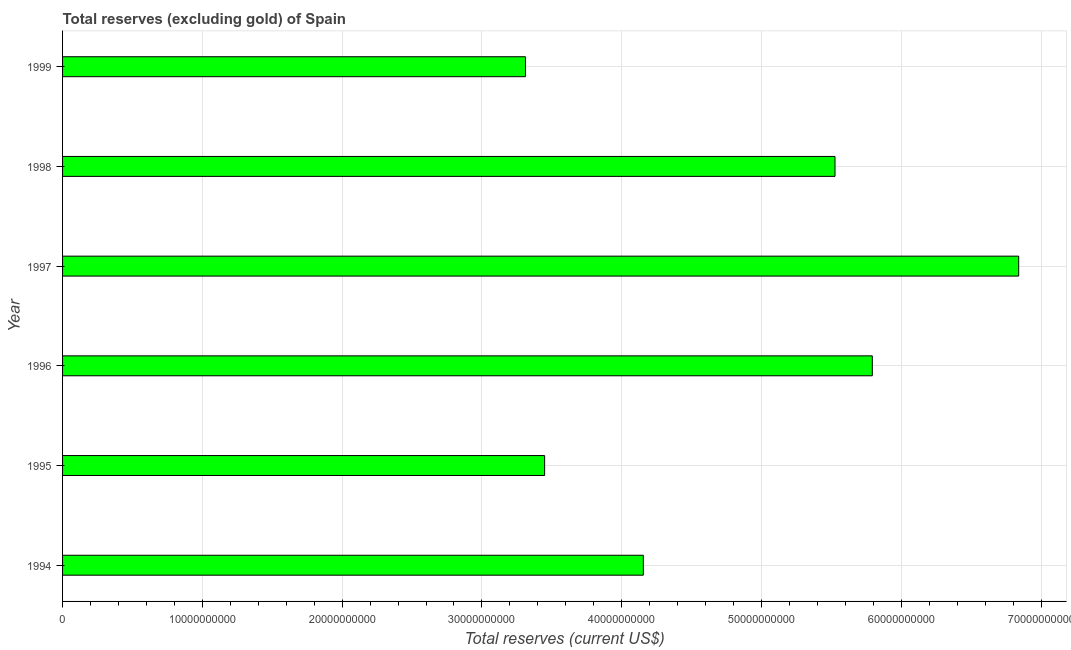Does the graph contain grids?
Offer a terse response. Yes. What is the title of the graph?
Your answer should be compact. Total reserves (excluding gold) of Spain. What is the label or title of the X-axis?
Your answer should be compact. Total reserves (current US$). What is the total reserves (excluding gold) in 1998?
Offer a terse response. 5.53e+1. Across all years, what is the maximum total reserves (excluding gold)?
Provide a succinct answer. 6.84e+1. Across all years, what is the minimum total reserves (excluding gold)?
Offer a terse response. 3.31e+1. In which year was the total reserves (excluding gold) maximum?
Give a very brief answer. 1997. What is the sum of the total reserves (excluding gold)?
Your response must be concise. 2.91e+11. What is the difference between the total reserves (excluding gold) in 1997 and 1998?
Keep it short and to the point. 1.31e+1. What is the average total reserves (excluding gold) per year?
Your answer should be very brief. 4.85e+1. What is the median total reserves (excluding gold)?
Your answer should be very brief. 4.84e+1. In how many years, is the total reserves (excluding gold) greater than 52000000000 US$?
Make the answer very short. 3. What is the ratio of the total reserves (excluding gold) in 1997 to that in 1998?
Keep it short and to the point. 1.24. What is the difference between the highest and the second highest total reserves (excluding gold)?
Ensure brevity in your answer.  1.05e+1. What is the difference between the highest and the lowest total reserves (excluding gold)?
Provide a short and direct response. 3.53e+1. In how many years, is the total reserves (excluding gold) greater than the average total reserves (excluding gold) taken over all years?
Offer a terse response. 3. Are all the bars in the graph horizontal?
Give a very brief answer. Yes. How many years are there in the graph?
Your response must be concise. 6. What is the difference between two consecutive major ticks on the X-axis?
Offer a terse response. 1.00e+1. What is the Total reserves (current US$) in 1994?
Keep it short and to the point. 4.15e+1. What is the Total reserves (current US$) in 1995?
Your answer should be compact. 3.45e+1. What is the Total reserves (current US$) of 1996?
Make the answer very short. 5.79e+1. What is the Total reserves (current US$) of 1997?
Make the answer very short. 6.84e+1. What is the Total reserves (current US$) of 1998?
Provide a succinct answer. 5.53e+1. What is the Total reserves (current US$) in 1999?
Offer a very short reply. 3.31e+1. What is the difference between the Total reserves (current US$) in 1994 and 1995?
Ensure brevity in your answer.  7.06e+09. What is the difference between the Total reserves (current US$) in 1994 and 1996?
Make the answer very short. -1.64e+1. What is the difference between the Total reserves (current US$) in 1994 and 1997?
Provide a succinct answer. -2.69e+1. What is the difference between the Total reserves (current US$) in 1994 and 1998?
Keep it short and to the point. -1.37e+1. What is the difference between the Total reserves (current US$) in 1994 and 1999?
Offer a terse response. 8.43e+09. What is the difference between the Total reserves (current US$) in 1995 and 1996?
Ensure brevity in your answer.  -2.34e+1. What is the difference between the Total reserves (current US$) in 1995 and 1997?
Keep it short and to the point. -3.39e+1. What is the difference between the Total reserves (current US$) in 1995 and 1998?
Make the answer very short. -2.08e+1. What is the difference between the Total reserves (current US$) in 1995 and 1999?
Ensure brevity in your answer.  1.37e+09. What is the difference between the Total reserves (current US$) in 1996 and 1997?
Make the answer very short. -1.05e+1. What is the difference between the Total reserves (current US$) in 1996 and 1998?
Offer a terse response. 2.67e+09. What is the difference between the Total reserves (current US$) in 1996 and 1999?
Your answer should be very brief. 2.48e+1. What is the difference between the Total reserves (current US$) in 1997 and 1998?
Your answer should be compact. 1.31e+1. What is the difference between the Total reserves (current US$) in 1997 and 1999?
Offer a very short reply. 3.53e+1. What is the difference between the Total reserves (current US$) in 1998 and 1999?
Your answer should be very brief. 2.21e+1. What is the ratio of the Total reserves (current US$) in 1994 to that in 1995?
Ensure brevity in your answer.  1.21. What is the ratio of the Total reserves (current US$) in 1994 to that in 1996?
Your answer should be very brief. 0.72. What is the ratio of the Total reserves (current US$) in 1994 to that in 1997?
Ensure brevity in your answer.  0.61. What is the ratio of the Total reserves (current US$) in 1994 to that in 1998?
Keep it short and to the point. 0.75. What is the ratio of the Total reserves (current US$) in 1994 to that in 1999?
Provide a short and direct response. 1.25. What is the ratio of the Total reserves (current US$) in 1995 to that in 1996?
Provide a succinct answer. 0.59. What is the ratio of the Total reserves (current US$) in 1995 to that in 1997?
Provide a succinct answer. 0.5. What is the ratio of the Total reserves (current US$) in 1995 to that in 1998?
Provide a short and direct response. 0.62. What is the ratio of the Total reserves (current US$) in 1995 to that in 1999?
Provide a short and direct response. 1.04. What is the ratio of the Total reserves (current US$) in 1996 to that in 1997?
Make the answer very short. 0.85. What is the ratio of the Total reserves (current US$) in 1996 to that in 1998?
Offer a very short reply. 1.05. What is the ratio of the Total reserves (current US$) in 1996 to that in 1999?
Make the answer very short. 1.75. What is the ratio of the Total reserves (current US$) in 1997 to that in 1998?
Provide a succinct answer. 1.24. What is the ratio of the Total reserves (current US$) in 1997 to that in 1999?
Make the answer very short. 2.06. What is the ratio of the Total reserves (current US$) in 1998 to that in 1999?
Your answer should be compact. 1.67. 